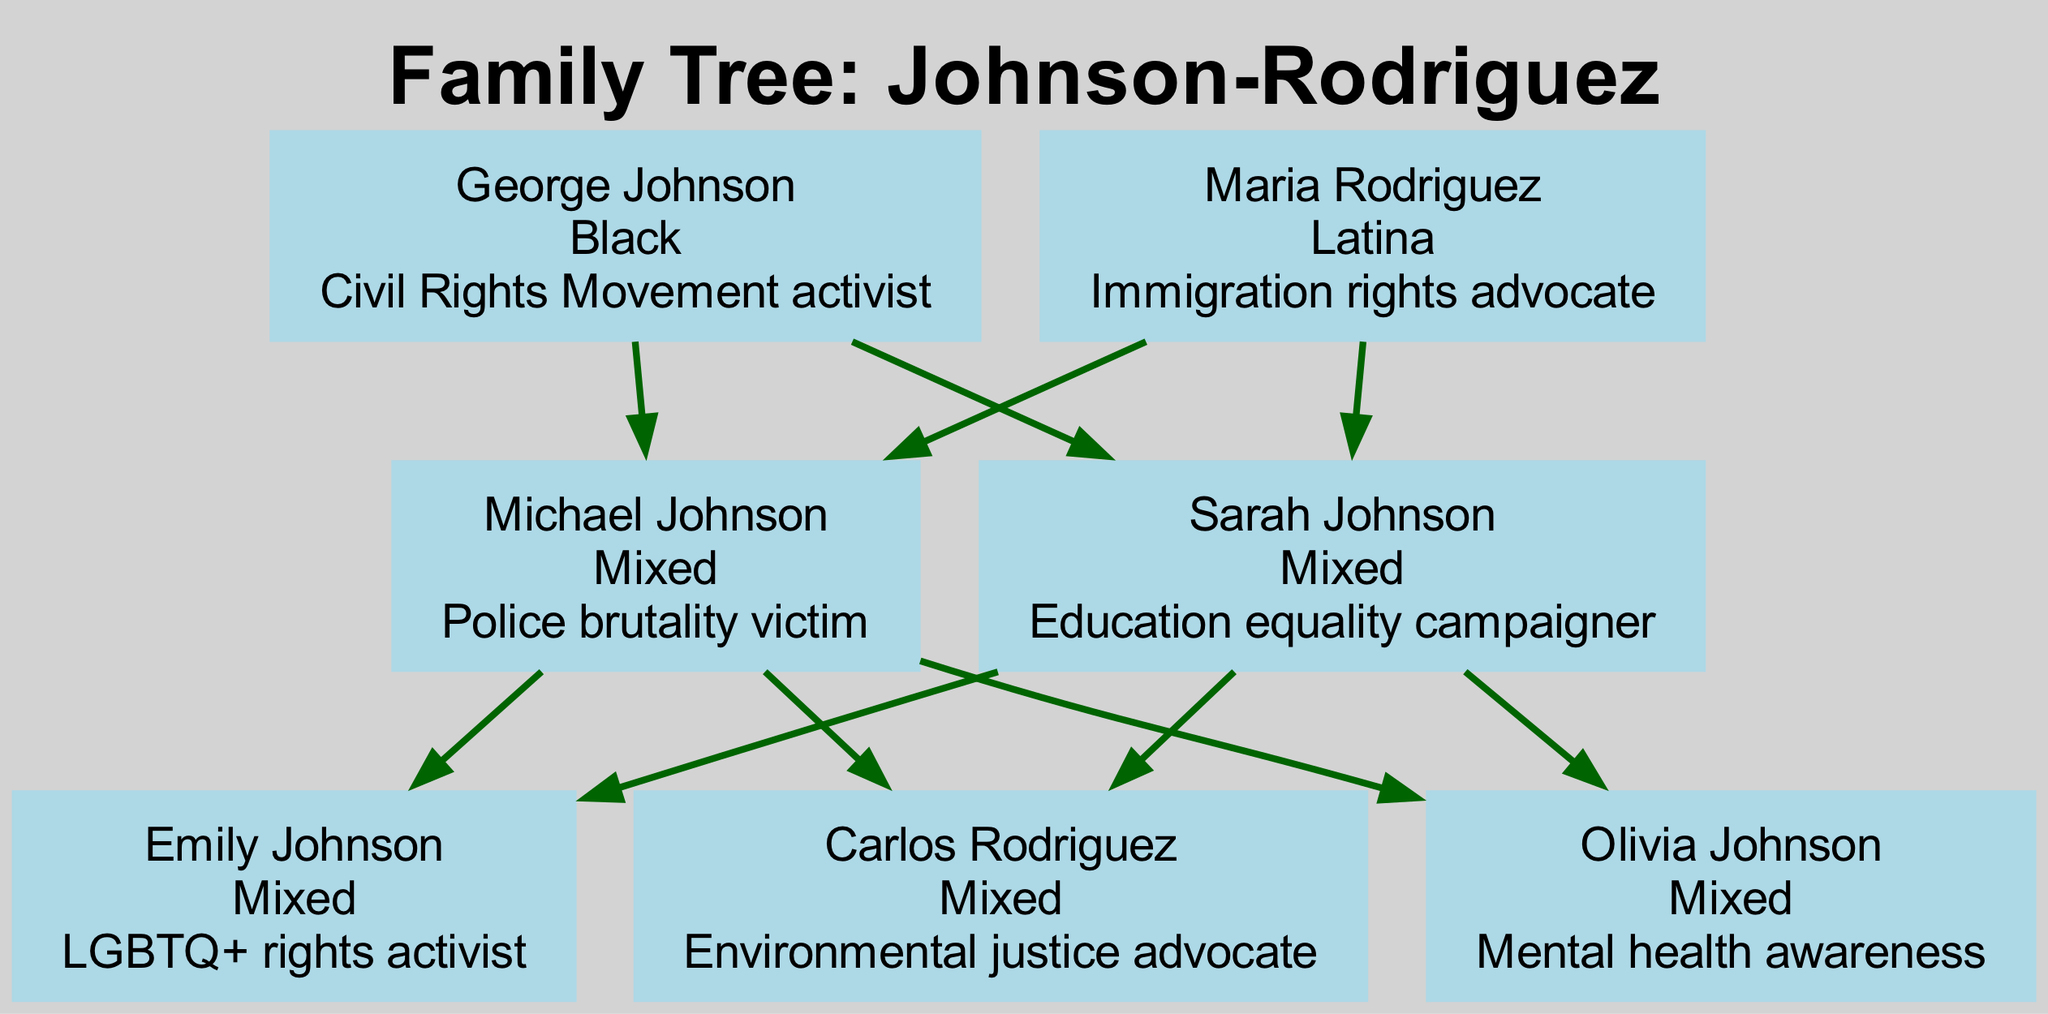What is the race of George Johnson? The diagram clearly indicates that George Johnson is categorized as "Black" in the race section.
Answer: Black How many generations are represented in the family tree? The diagram shows distinct groupings for each generation: Generation 1, Generation 2, and Generation 3, making it a total of three generations.
Answer: 3 Who is the advocate for immigration rights in the family? Among the names listed in Generation 1, Maria Rodriguez is specifically noted as the "Immigration rights advocate."
Answer: Maria Rodriguez Which character is a victim of police brutality? In Generation 2, Michael Johnson is marked as the "Police brutality victim," making him the character associated with that issue.
Answer: Michael Johnson What issue does Olivia Johnson focus on? According to the diagram, Olivia Johnson is noted for her work on "Mental health awareness," indicating her focus on that specific social issue.
Answer: Mental health awareness How many characters are there in Generation 3? By counting the names listed in Generation 3, we find Emily Johnson, Carlos Rodriguez, and Olivia Johnson, totaling three characters.
Answer: 3 Which generation has an education equality campaigner? Looking at Generation 2, we see that Sarah Johnson is identified as the "Education equality campaigner," making her the representative for this issue in that generation.
Answer: Generation 2 Who is connected to both George Johnson and Sarah Johnson? George Johnson is in Generation 1, and Sarah Johnson is in Generation 2. Michael Johnson is the child of George and the sibling of Sarah, thus connecting them through parent-child relationships.
Answer: Michael Johnson What social issue is tackled by Carlos Rodriguez? The diagram specifies that Carlos Rodriguez is involved in "Environmental justice advocacy," highlighting his focus on that important social issue.
Answer: Environmental justice advocate 